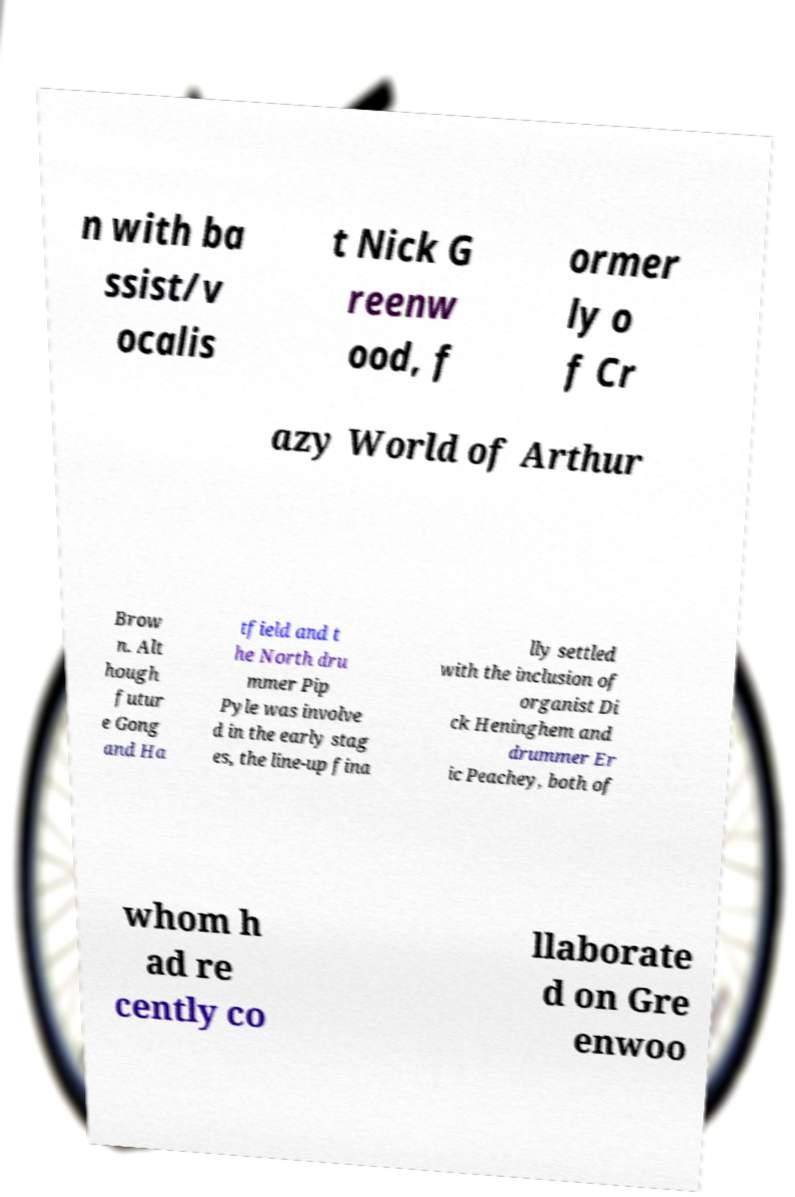What messages or text are displayed in this image? I need them in a readable, typed format. n with ba ssist/v ocalis t Nick G reenw ood, f ormer ly o f Cr azy World of Arthur Brow n. Alt hough futur e Gong and Ha tfield and t he North dru mmer Pip Pyle was involve d in the early stag es, the line-up fina lly settled with the inclusion of organist Di ck Heninghem and drummer Er ic Peachey, both of whom h ad re cently co llaborate d on Gre enwoo 